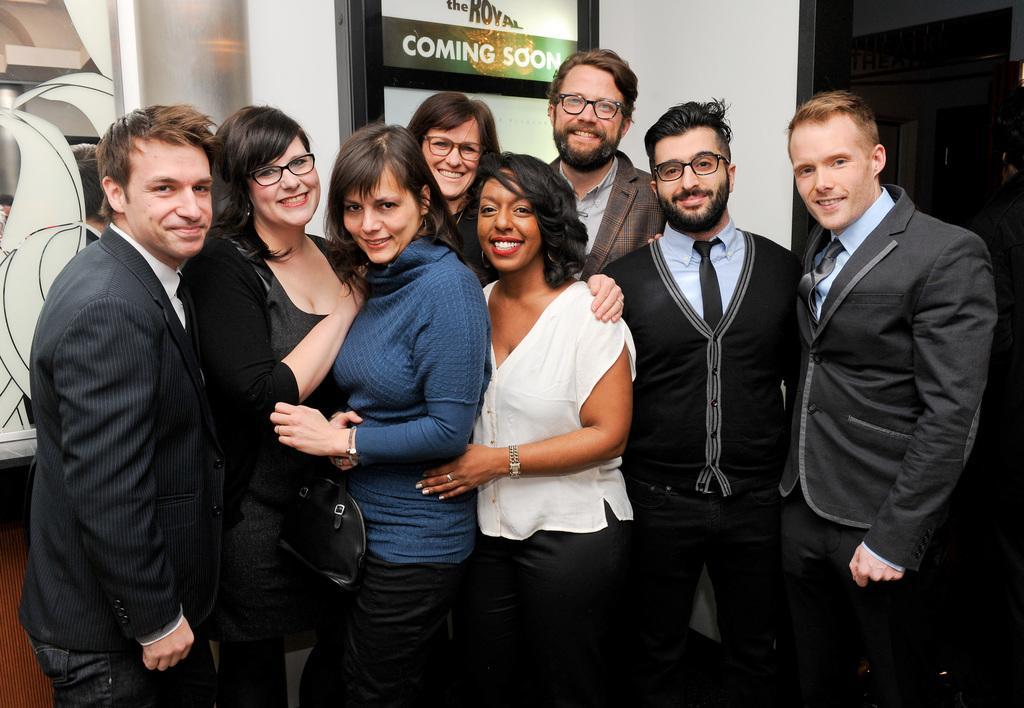Can you describe this image briefly? In this picture we can see a group of people standing and smiling. There is some text visible on the door. We can see a white object and a person on the left side. There is some text and a wooden object is visible on the right side. 